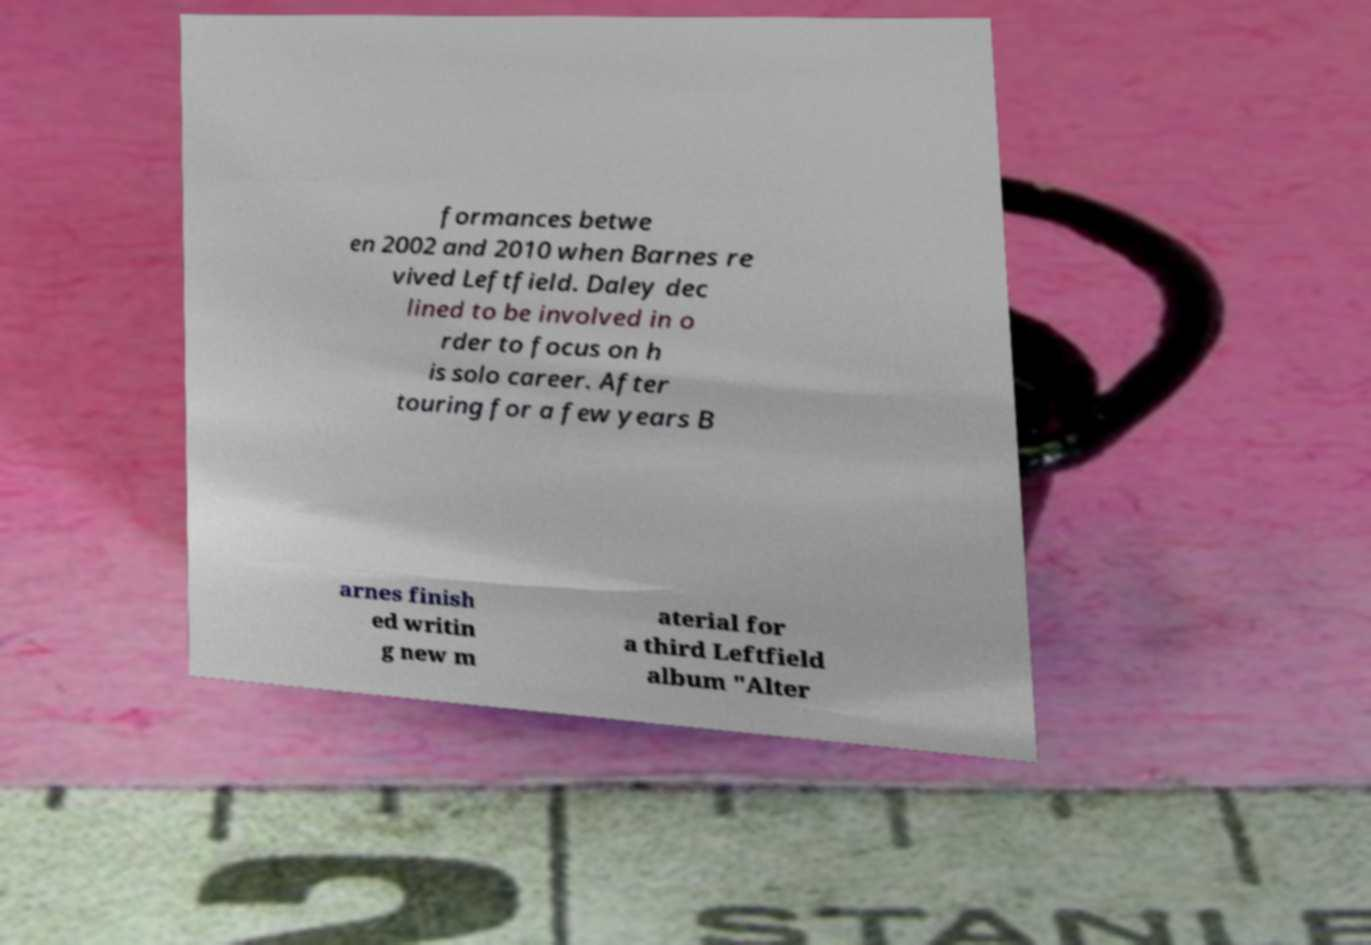I need the written content from this picture converted into text. Can you do that? formances betwe en 2002 and 2010 when Barnes re vived Leftfield. Daley dec lined to be involved in o rder to focus on h is solo career. After touring for a few years B arnes finish ed writin g new m aterial for a third Leftfield album "Alter 